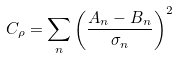Convert formula to latex. <formula><loc_0><loc_0><loc_500><loc_500>C _ { \rho } = \sum _ { n } \left ( \frac { A _ { n } - B _ { n } } { \sigma _ { n } } \right ) ^ { 2 }</formula> 